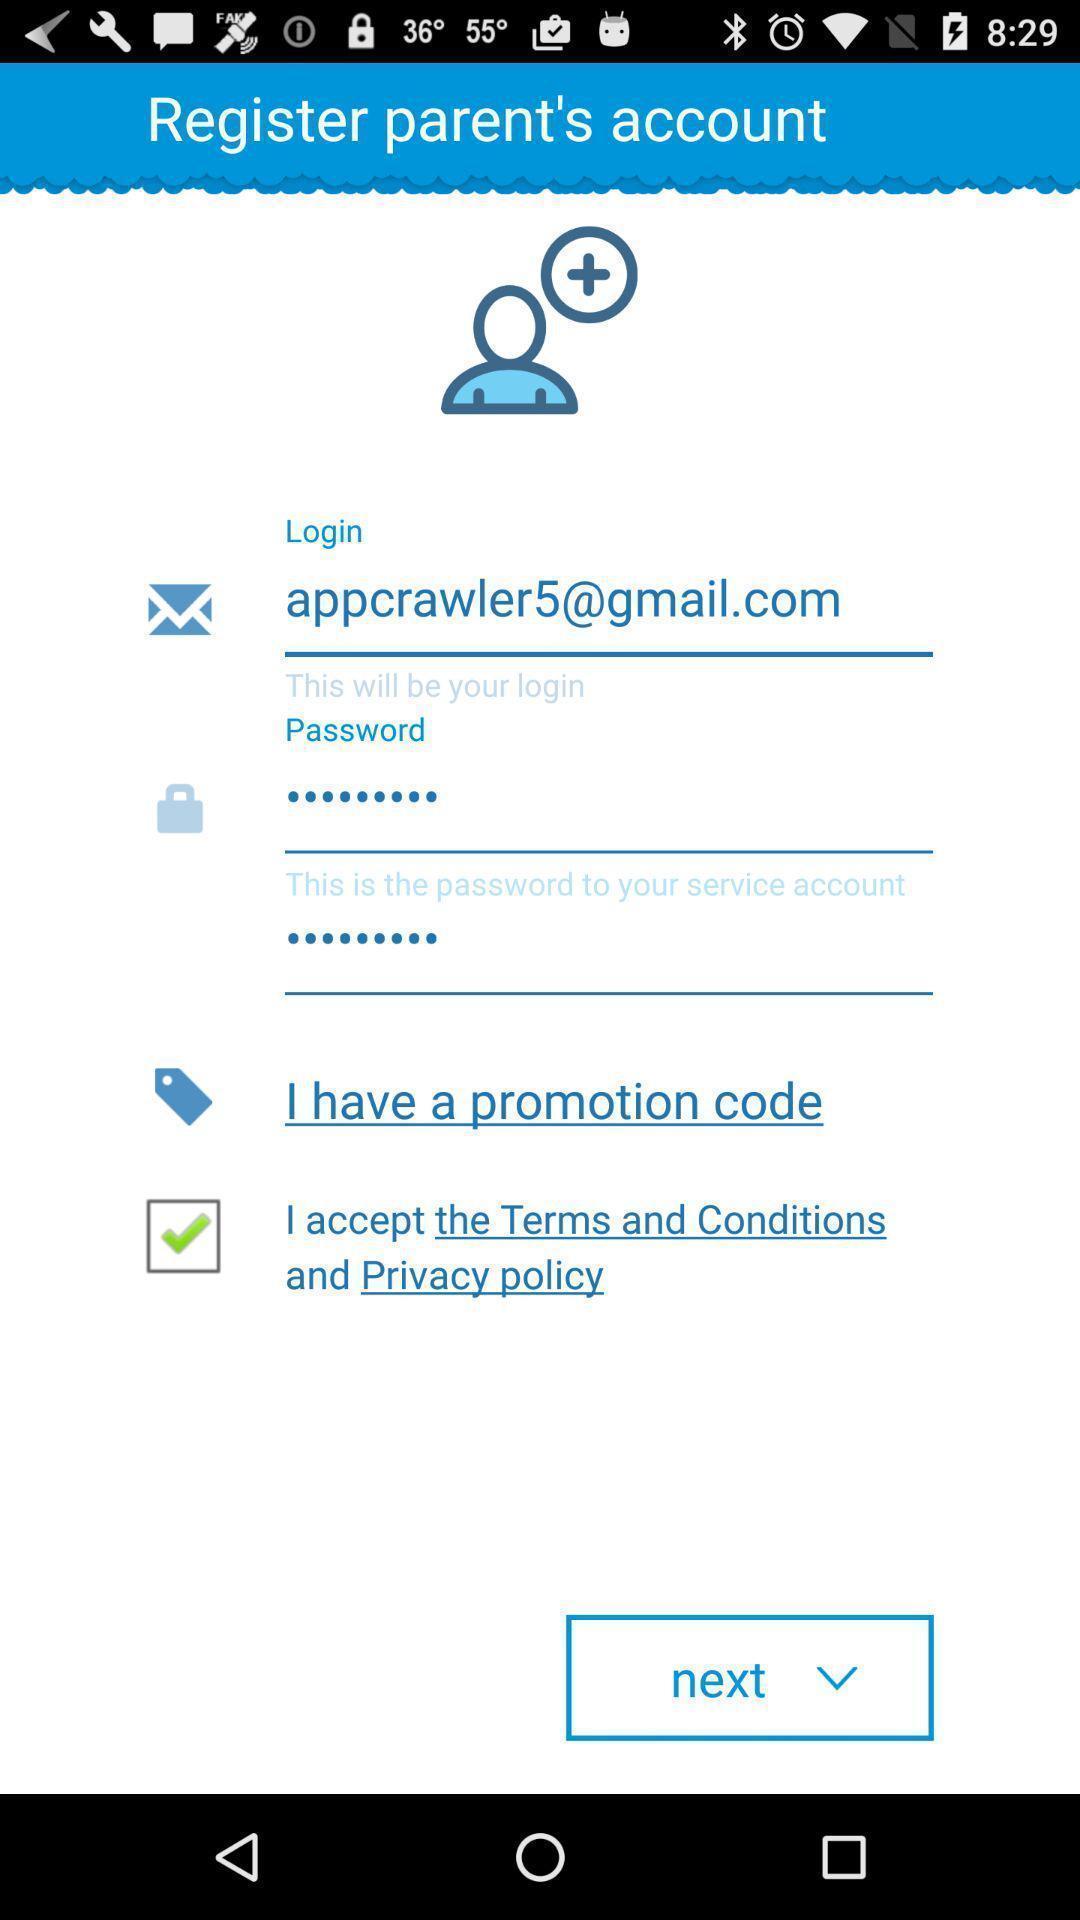Describe the key features of this screenshot. Screen shows register parents account details in app. 